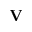<formula> <loc_0><loc_0><loc_500><loc_500>{ V }</formula> 